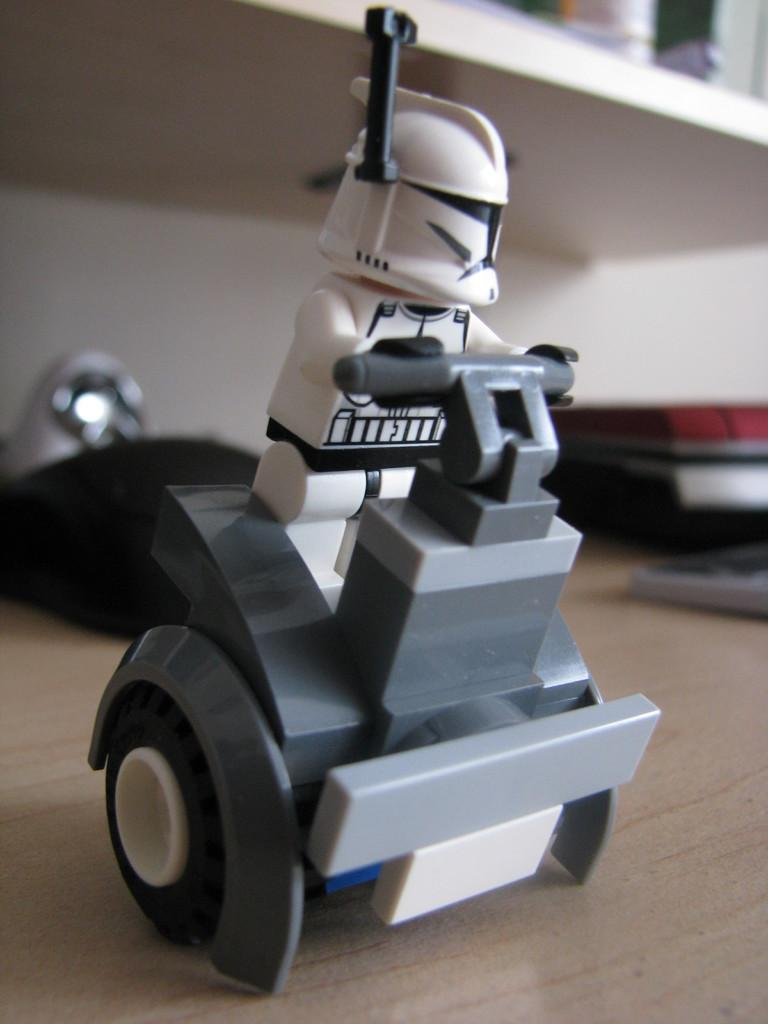What type of object can be seen in the image? There is a toy in the image. What else can be seen in the image besides the toy? There are books and other objects on a wooden surface in the image. Can you describe the background of the image? The background of the image is blurred. What type of bird is sitting on the partner's shoulder in the image? There is no partner or bird present in the image. 